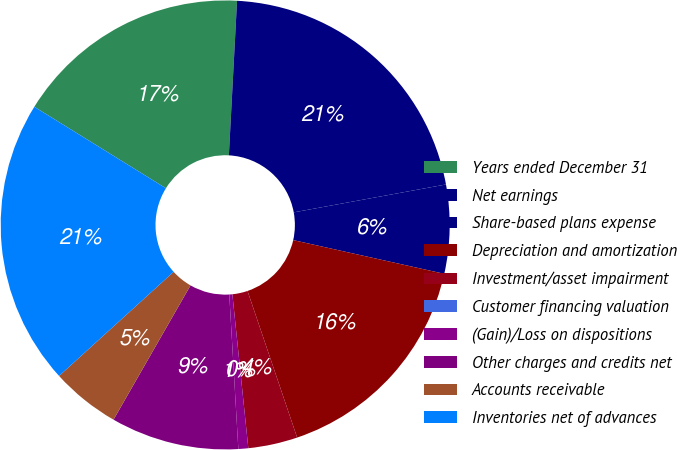Convert chart to OTSL. <chart><loc_0><loc_0><loc_500><loc_500><pie_chart><fcel>Years ended December 31<fcel>Net earnings<fcel>Share-based plans expense<fcel>Depreciation and amortization<fcel>Investment/asset impairment<fcel>Customer financing valuation<fcel>(Gain)/Loss on dispositions<fcel>Other charges and credits net<fcel>Accounts receivable<fcel>Inventories net of advances<nl><fcel>17.02%<fcel>21.27%<fcel>6.38%<fcel>16.31%<fcel>3.55%<fcel>0.0%<fcel>0.71%<fcel>9.22%<fcel>4.97%<fcel>20.56%<nl></chart> 